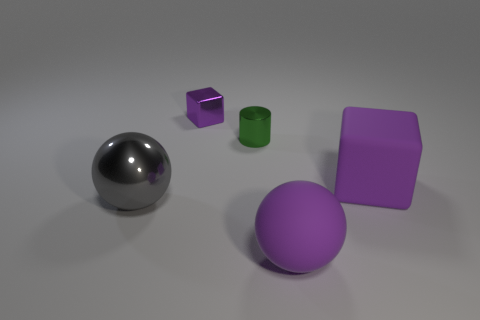Subtract all spheres. How many objects are left? 3 Subtract all red cylinders. Subtract all red balls. How many cylinders are left? 1 Subtract all green cylinders. How many yellow blocks are left? 0 Subtract all green cylinders. Subtract all large balls. How many objects are left? 2 Add 2 spheres. How many spheres are left? 4 Add 5 small blue rubber cylinders. How many small blue rubber cylinders exist? 5 Add 4 brown cylinders. How many objects exist? 9 Subtract all gray balls. How many balls are left? 1 Subtract 1 purple spheres. How many objects are left? 4 